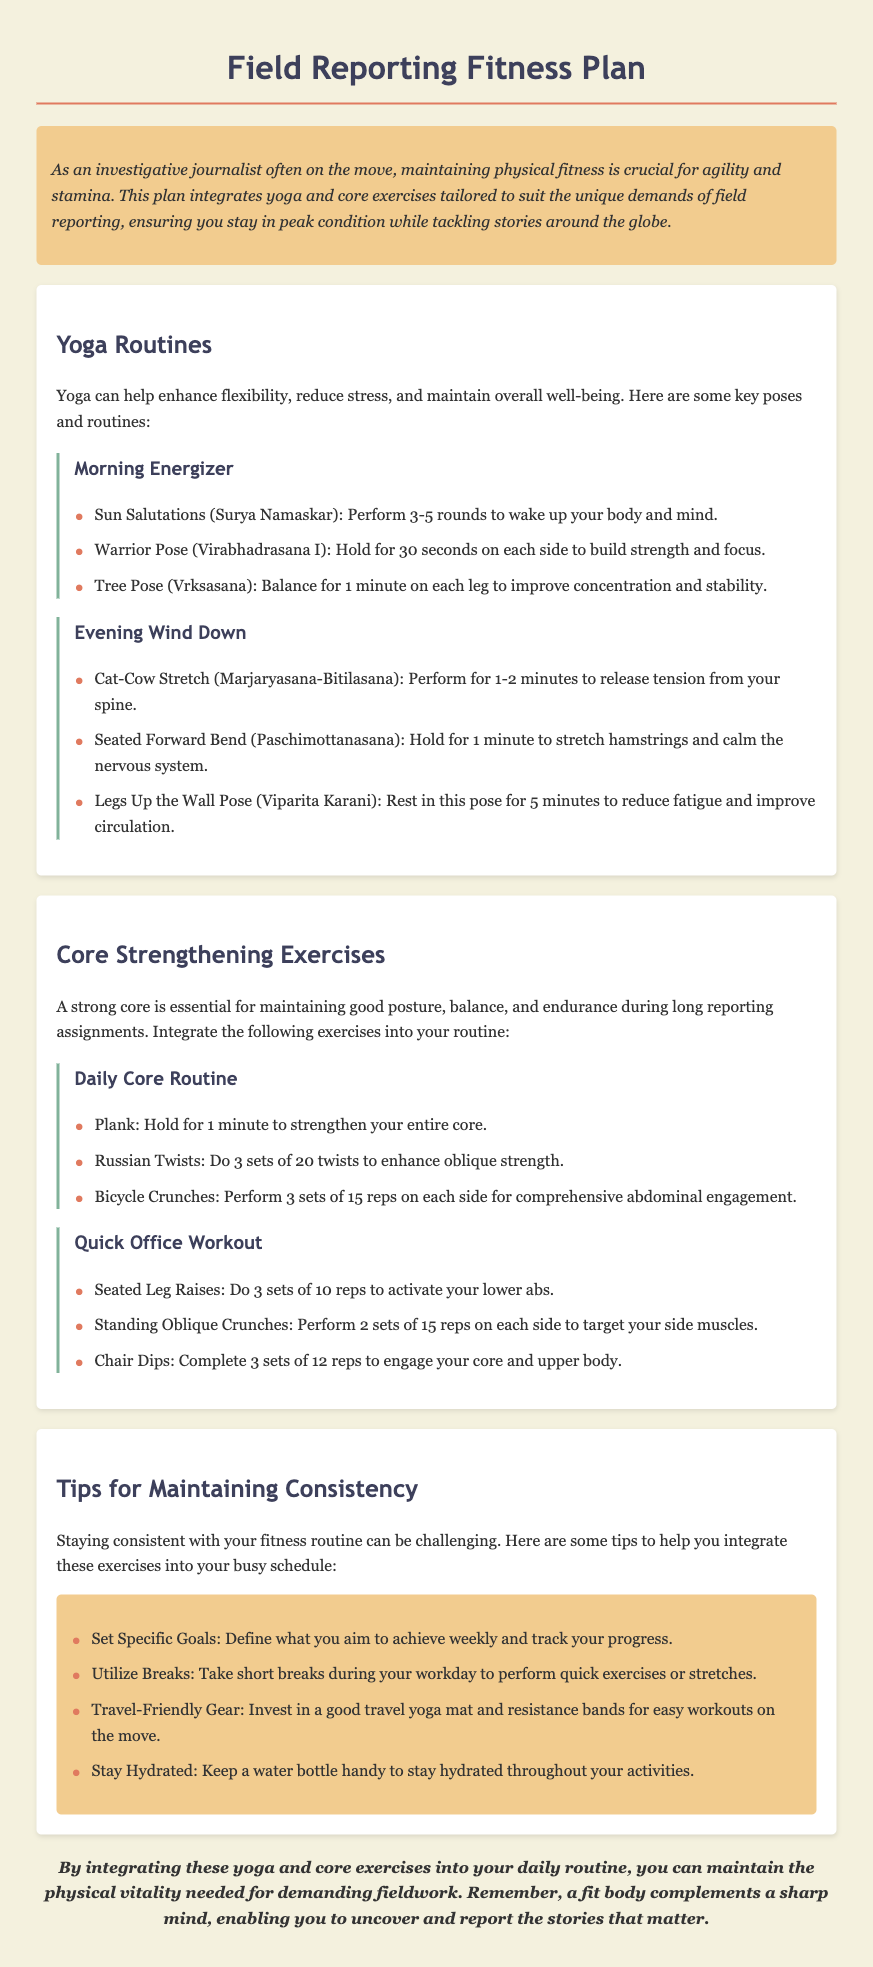what is the title of the document? The title is prominently displayed at the top of the document, clearly indicating the fitness plan.
Answer: Field Reporting Fitness Plan how many rounds of Sun Salutations should be performed? The document specifies performing 3-5 rounds of Sun Salutations in the Morning Energizer section.
Answer: 3-5 rounds what is the duration for holding the Warrior Pose? The duration for holding Warrior Pose as mentioned in the document is 30 seconds on each side.
Answer: 30 seconds what is one tip for maintaining consistency with workouts? The document lists several tips, one being to define specific goals for tracking progress.
Answer: Set Specific Goals how many reps are suggested for Bicycle Crunches? The recommended number of reps for Bicycle Crunches is detailed in the Daily Core Routine section.
Answer: 15 reps which yoga pose is recommended to release tension from the spine? The document mentions Cat-Cow Stretch as the pose for releasing tension from the spine in the Evening Wind Down section.
Answer: Cat-Cow Stretch how many sets of Russian Twists should be performed? The document indicates doing 3 sets of 20 twists for the Russian Twists exercise.
Answer: 3 sets of 20 what is the main purpose of the Field Reporting Fitness Plan? The purpose is outlined in the introductory section, emphasizing the need for physical fitness for journalists.
Answer: Maintain physical fitness which exercise is suggested for a quick office workout? The document lists several, including Seated Leg Raises, as part of the quick office workout.
Answer: Seated Leg Raises 